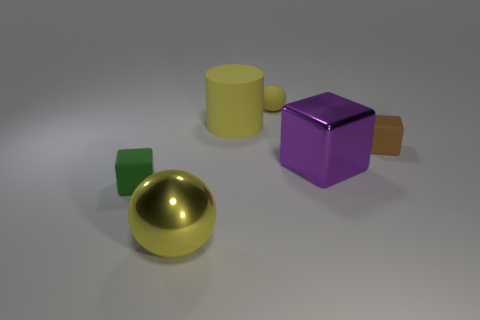Add 3 big blue rubber spheres. How many objects exist? 9 Subtract all cylinders. How many objects are left? 5 Subtract all purple rubber objects. Subtract all metallic balls. How many objects are left? 5 Add 6 yellow metal balls. How many yellow metal balls are left? 7 Add 1 big balls. How many big balls exist? 2 Subtract 1 purple blocks. How many objects are left? 5 